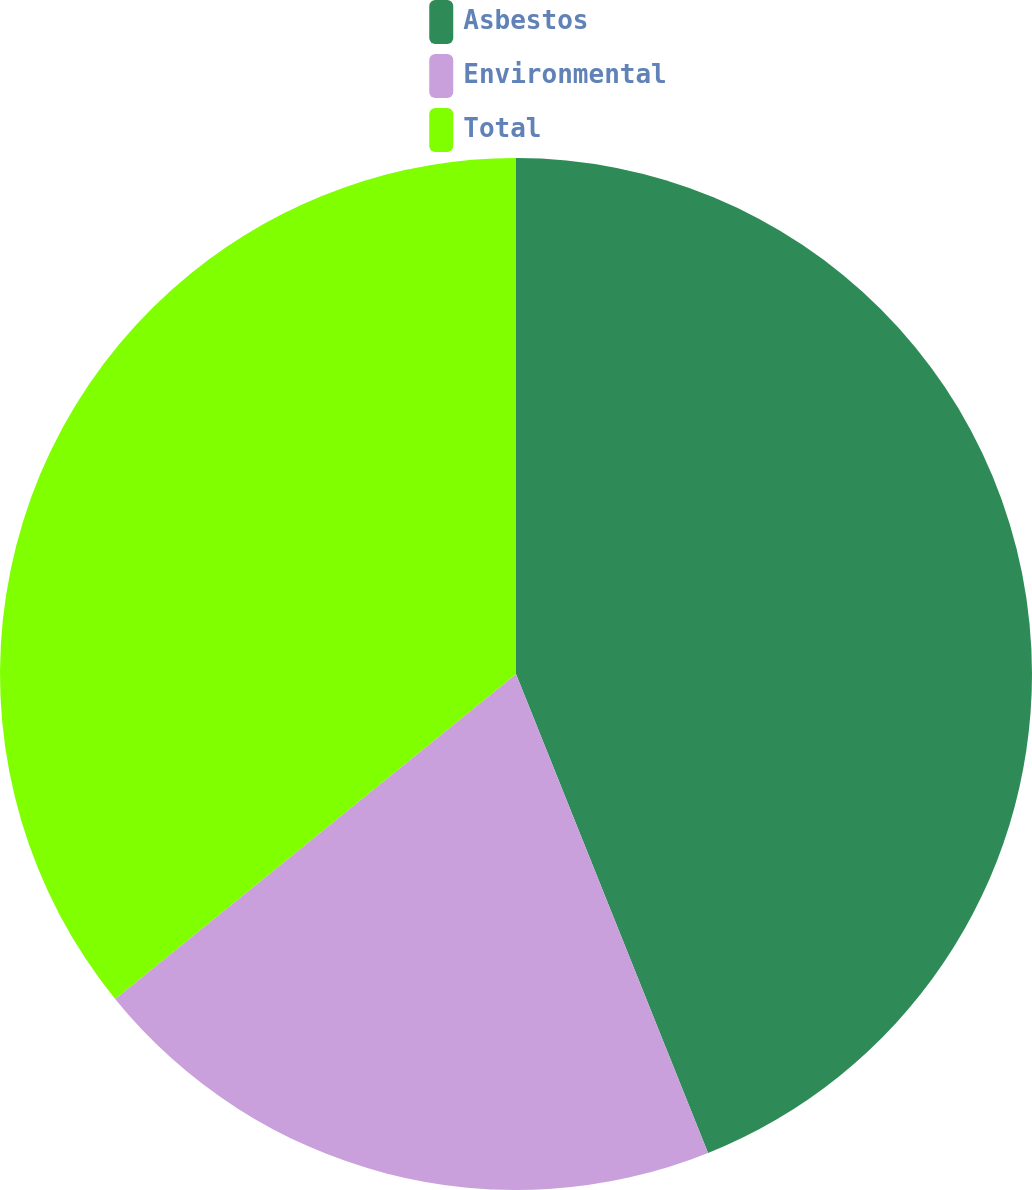<chart> <loc_0><loc_0><loc_500><loc_500><pie_chart><fcel>Asbestos<fcel>Environmental<fcel>Total<nl><fcel>43.93%<fcel>20.23%<fcel>35.84%<nl></chart> 